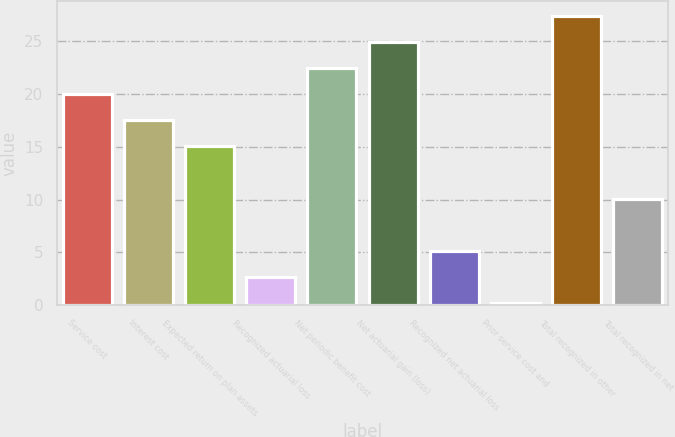Convert chart. <chart><loc_0><loc_0><loc_500><loc_500><bar_chart><fcel>Service cost<fcel>Interest cost<fcel>Expected return on plan assets<fcel>Recognized actuarial loss<fcel>Net periodic benefit cost<fcel>Net actuarial gain (loss)<fcel>Recognized net actuarial loss<fcel>Prior service cost and<fcel>Total recognized in other<fcel>Total recognized in net<nl><fcel>19.96<fcel>17.49<fcel>15.02<fcel>2.67<fcel>22.43<fcel>24.9<fcel>5.14<fcel>0.2<fcel>27.37<fcel>10.08<nl></chart> 